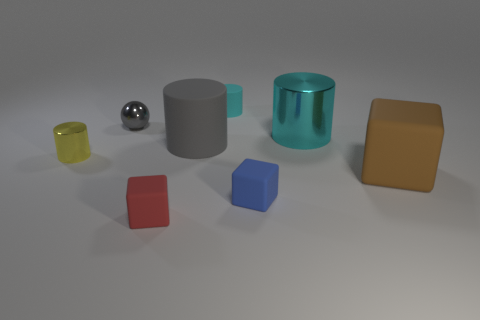How many objects in the image have a transparent or translucent quality? There is one object in the image that displays a transparent or translucent quality, and that is the small yellow glass on the far left. It allows light to pass through, revealing its contents and the surface below it. 